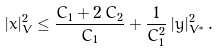Convert formula to latex. <formula><loc_0><loc_0><loc_500><loc_500>| x | _ { V } ^ { 2 } \leq \frac { C _ { 1 } + 2 \, C _ { 2 } } { C _ { 1 } } + \frac { 1 } { C _ { 1 } ^ { 2 } } \, | y | _ { V ^ { * } } ^ { 2 } \, .</formula> 